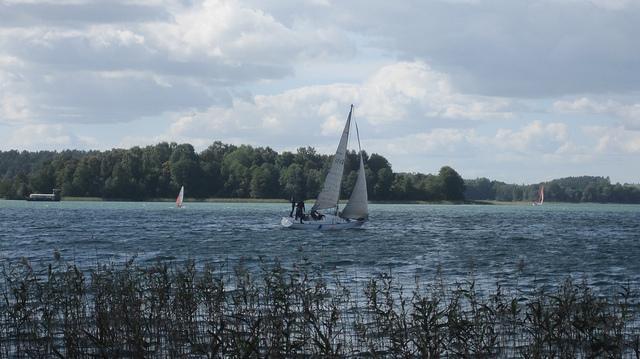How many boats are in the water?
Give a very brief answer. 3. How many boats are there?
Give a very brief answer. 1. How many white toilets with brown lids are in this image?
Give a very brief answer. 0. 